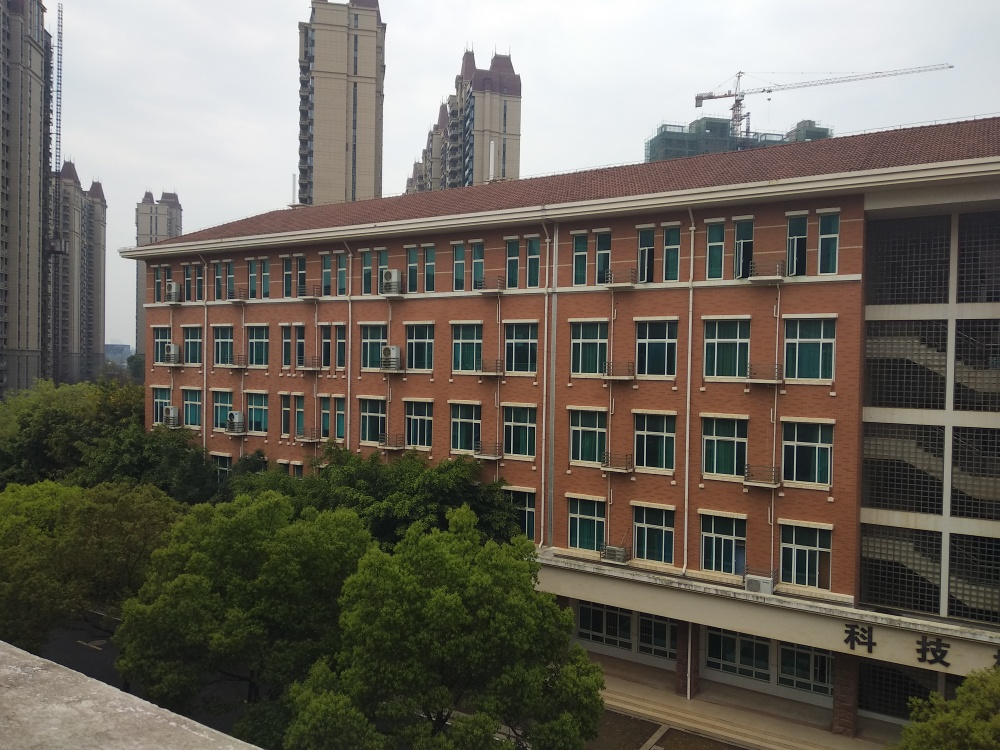Could you tell me about the area surrounding the building? Certainly. The building appears to be situated in a well-developed urban area, with high-rise buildings nearby, indicative of a bustling city environment. The mature trees in the forefront suggest an attempt to incorporate green spaces within this urban setting, which could provide a visual break and natural atmosphere amidst the dense construction. How might the area be used by people during the day? During the day, areas like this one likely serve a variety of purposes. The building itself might house offices or educational facilities, and the green space could be a spot for relaxation or casual meetings. The juxtaposition of work and leisure spaces suggests that the area can cater to both professional and personal needs of the city's residents and visitors. 